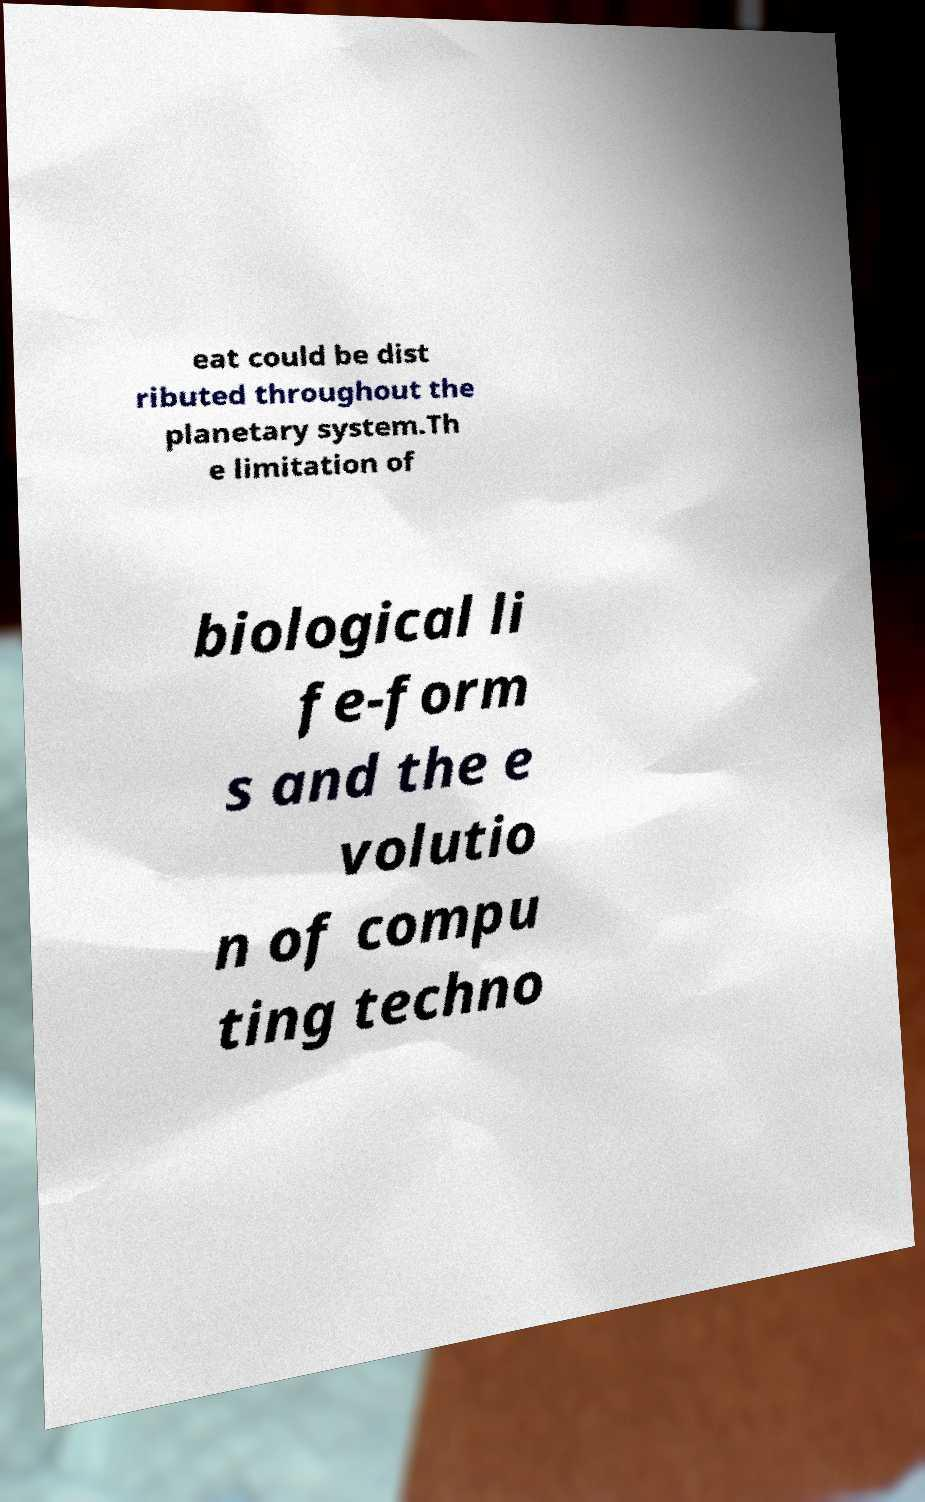For documentation purposes, I need the text within this image transcribed. Could you provide that? eat could be dist ributed throughout the planetary system.Th e limitation of biological li fe-form s and the e volutio n of compu ting techno 